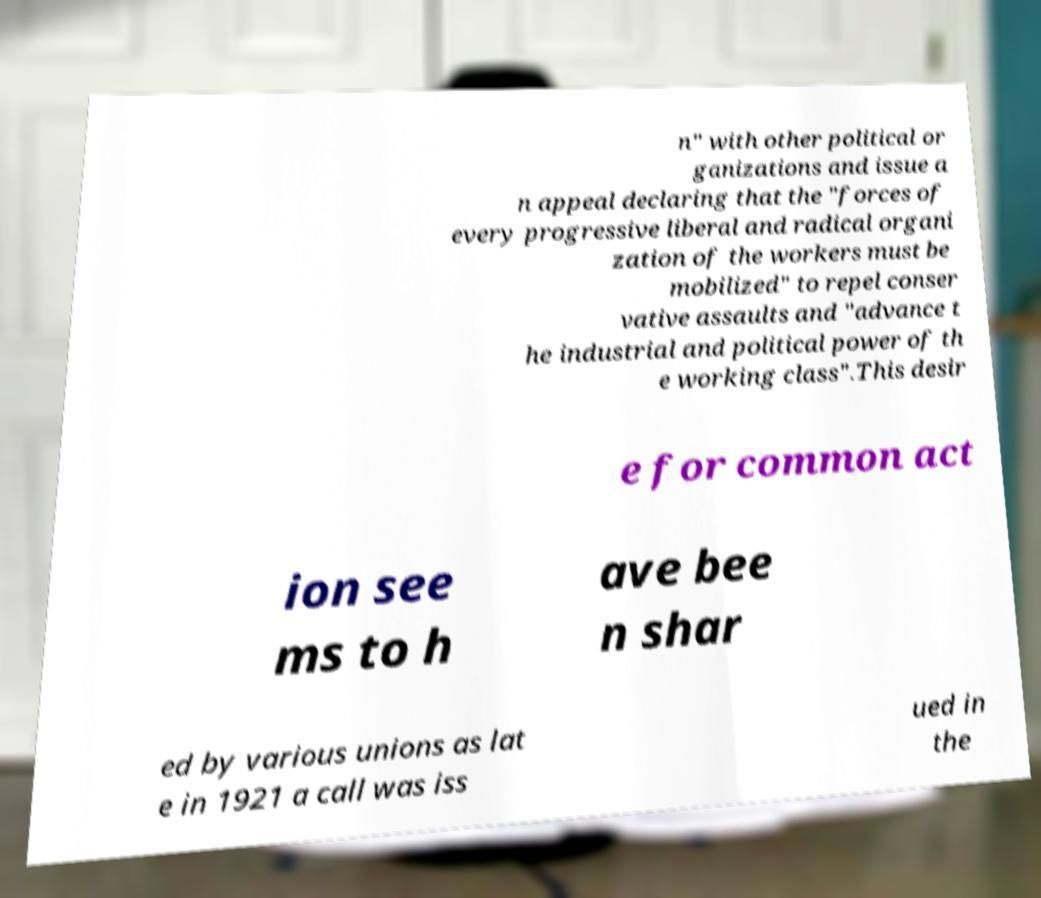Can you accurately transcribe the text from the provided image for me? n" with other political or ganizations and issue a n appeal declaring that the "forces of every progressive liberal and radical organi zation of the workers must be mobilized" to repel conser vative assaults and "advance t he industrial and political power of th e working class".This desir e for common act ion see ms to h ave bee n shar ed by various unions as lat e in 1921 a call was iss ued in the 